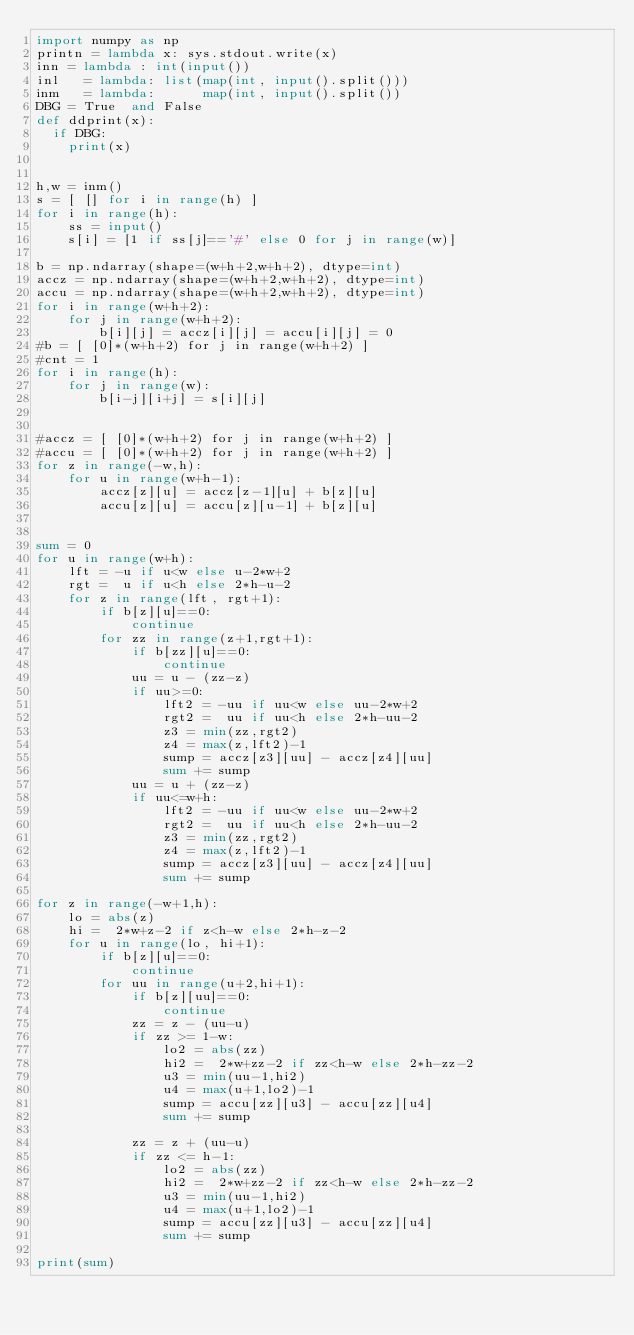Convert code to text. <code><loc_0><loc_0><loc_500><loc_500><_Python_>import numpy as np
printn = lambda x: sys.stdout.write(x)
inn = lambda : int(input())
inl   = lambda: list(map(int, input().split()))
inm   = lambda:      map(int, input().split())
DBG = True  and False
def ddprint(x):
  if DBG:
    print(x)


h,w = inm()
s = [ [] for i in range(h) ]
for i in range(h):
    ss = input()
    s[i] = [1 if ss[j]=='#' else 0 for j in range(w)]

b = np.ndarray(shape=(w+h+2,w+h+2), dtype=int)
accz = np.ndarray(shape=(w+h+2,w+h+2), dtype=int)
accu = np.ndarray(shape=(w+h+2,w+h+2), dtype=int)
for i in range(w+h+2):
    for j in range(w+h+2):
        b[i][j] = accz[i][j] = accu[i][j] = 0
#b = [ [0]*(w+h+2) for j in range(w+h+2) ]
#cnt = 1
for i in range(h):
    for j in range(w):
        b[i-j][i+j] = s[i][j]


#accz = [ [0]*(w+h+2) for j in range(w+h+2) ]
#accu = [ [0]*(w+h+2) for j in range(w+h+2) ]
for z in range(-w,h):
    for u in range(w+h-1):
        accz[z][u] = accz[z-1][u] + b[z][u]
        accu[z][u] = accu[z][u-1] + b[z][u]


sum = 0
for u in range(w+h):
    lft = -u if u<w else u-2*w+2
    rgt =  u if u<h else 2*h-u-2
    for z in range(lft, rgt+1):
        if b[z][u]==0:
            continue
        for zz in range(z+1,rgt+1):
            if b[zz][u]==0:
                continue
            uu = u - (zz-z)
            if uu>=0:
                lft2 = -uu if uu<w else uu-2*w+2
                rgt2 =  uu if uu<h else 2*h-uu-2
                z3 = min(zz,rgt2)
                z4 = max(z,lft2)-1
                sump = accz[z3][uu] - accz[z4][uu]
                sum += sump
            uu = u + (zz-z)
            if uu<=w+h:
                lft2 = -uu if uu<w else uu-2*w+2
                rgt2 =  uu if uu<h else 2*h-uu-2
                z3 = min(zz,rgt2)
                z4 = max(z,lft2)-1
                sump = accz[z3][uu] - accz[z4][uu]
                sum += sump

for z in range(-w+1,h):
    lo = abs(z)
    hi =  2*w+z-2 if z<h-w else 2*h-z-2
    for u in range(lo, hi+1):
        if b[z][u]==0:
            continue
        for uu in range(u+2,hi+1):
            if b[z][uu]==0:
                continue
            zz = z - (uu-u)
            if zz >= 1-w:
                lo2 = abs(zz)
                hi2 =  2*w+zz-2 if zz<h-w else 2*h-zz-2
                u3 = min(uu-1,hi2)
                u4 = max(u+1,lo2)-1
                sump = accu[zz][u3] - accu[zz][u4]
                sum += sump

            zz = z + (uu-u)
            if zz <= h-1:
                lo2 = abs(zz)
                hi2 =  2*w+zz-2 if zz<h-w else 2*h-zz-2
                u3 = min(uu-1,hi2)
                u4 = max(u+1,lo2)-1
                sump = accu[zz][u3] - accu[zz][u4]
                sum += sump

print(sum)
</code> 